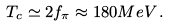Convert formula to latex. <formula><loc_0><loc_0><loc_500><loc_500>T _ { c } \simeq 2 f _ { \pi } \approx 1 8 0 M e V \, .</formula> 